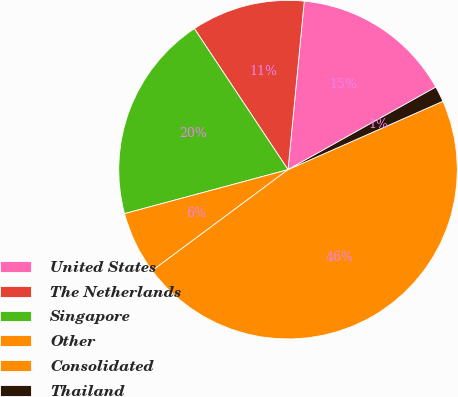<chart> <loc_0><loc_0><loc_500><loc_500><pie_chart><fcel>United States<fcel>The Netherlands<fcel>Singapore<fcel>Other<fcel>Consolidated<fcel>Thailand<nl><fcel>15.36%<fcel>10.86%<fcel>19.85%<fcel>5.99%<fcel>46.44%<fcel>1.49%<nl></chart> 